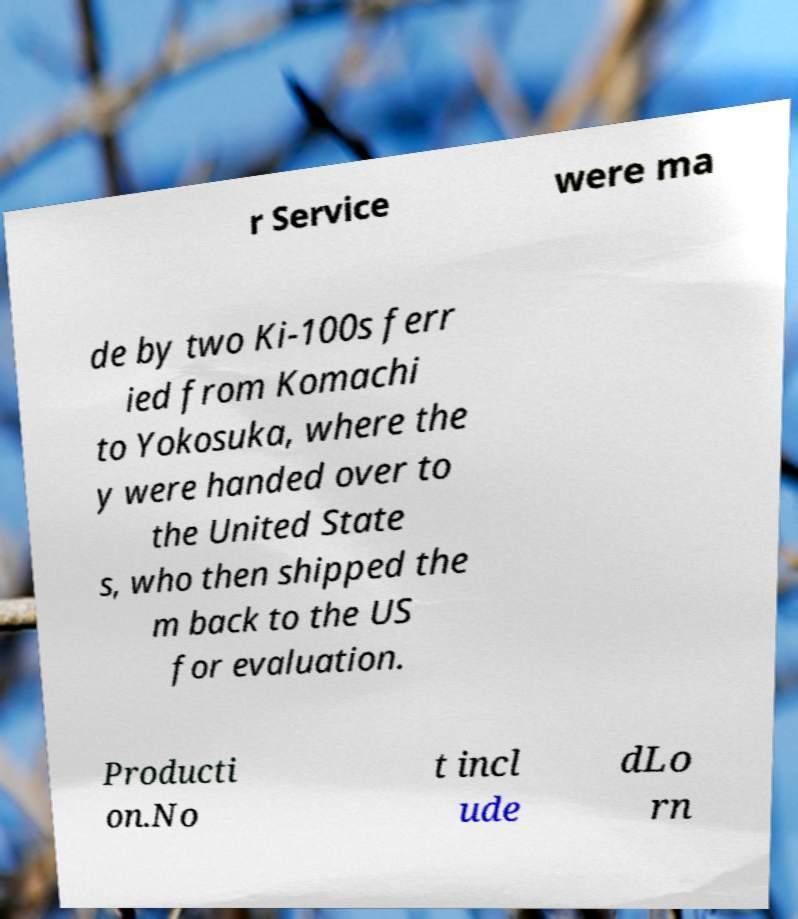Could you assist in decoding the text presented in this image and type it out clearly? r Service were ma de by two Ki-100s ferr ied from Komachi to Yokosuka, where the y were handed over to the United State s, who then shipped the m back to the US for evaluation. Producti on.No t incl ude dLo rn 